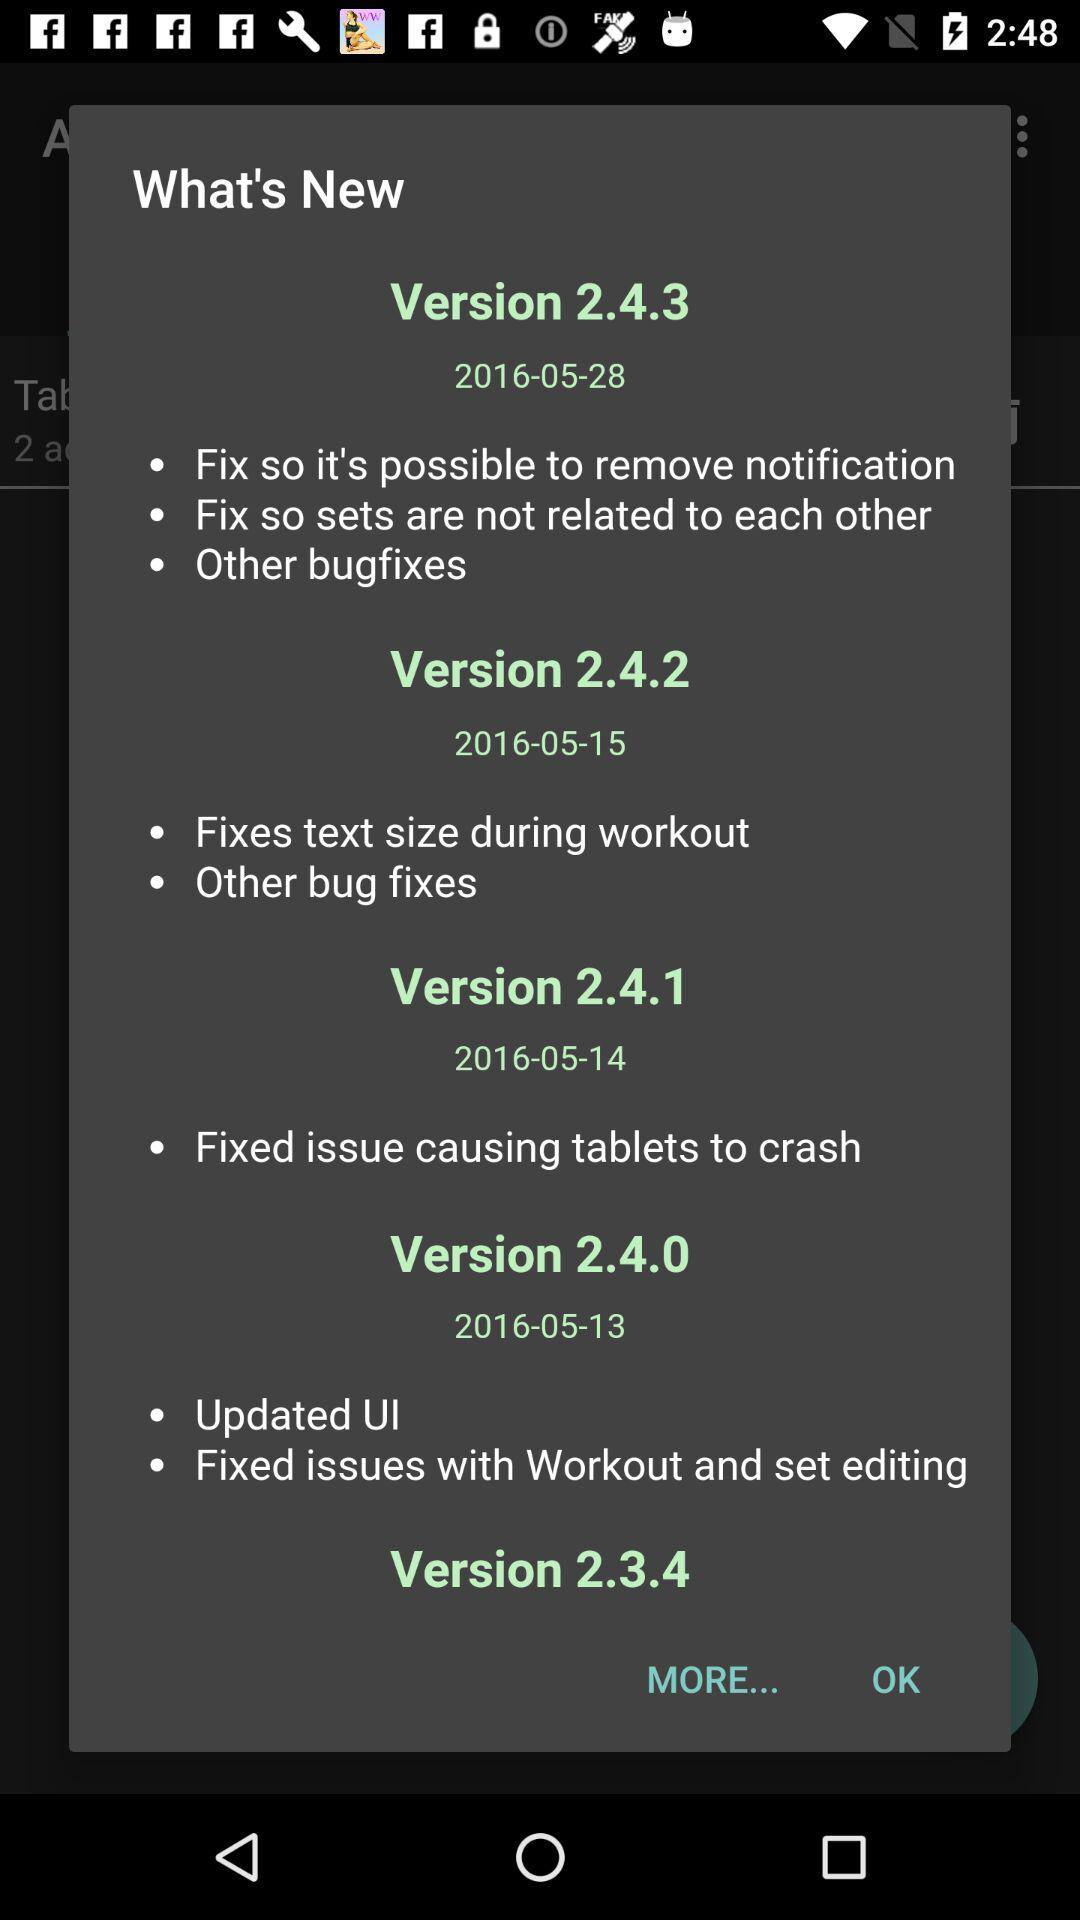How many bug fixes have been released since May 13th?
Answer the question using a single word or phrase. 4 